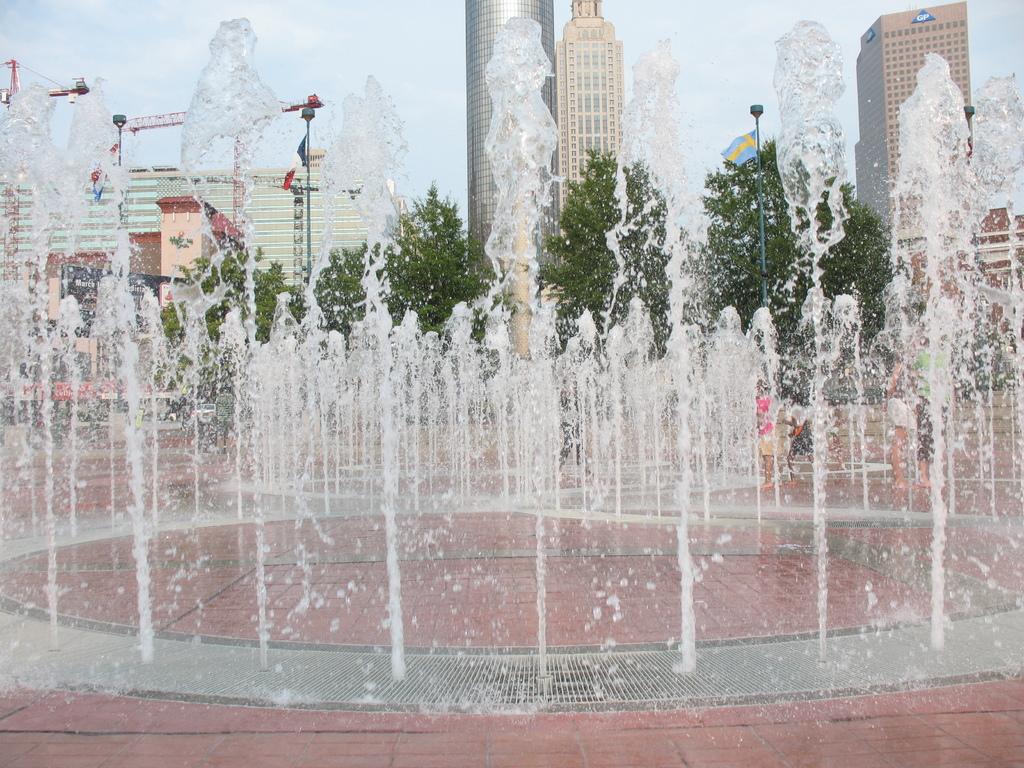Describe this image in one or two sentences. In this picture I can see there is a fountain here and there are some people standing. In the background there are trees, buildings and the sky is clear. 